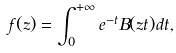<formula> <loc_0><loc_0><loc_500><loc_500>f ( z ) = \int _ { 0 } ^ { + \infty } e ^ { - t } B ( z t ) d t ,</formula> 